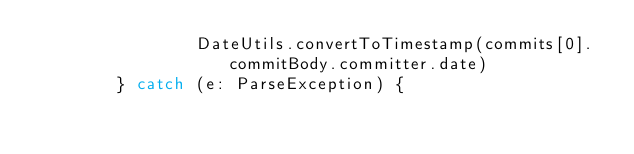Convert code to text. <code><loc_0><loc_0><loc_500><loc_500><_Kotlin_>                DateUtils.convertToTimestamp(commits[0].commitBody.committer.date)
        } catch (e: ParseException) {</code> 